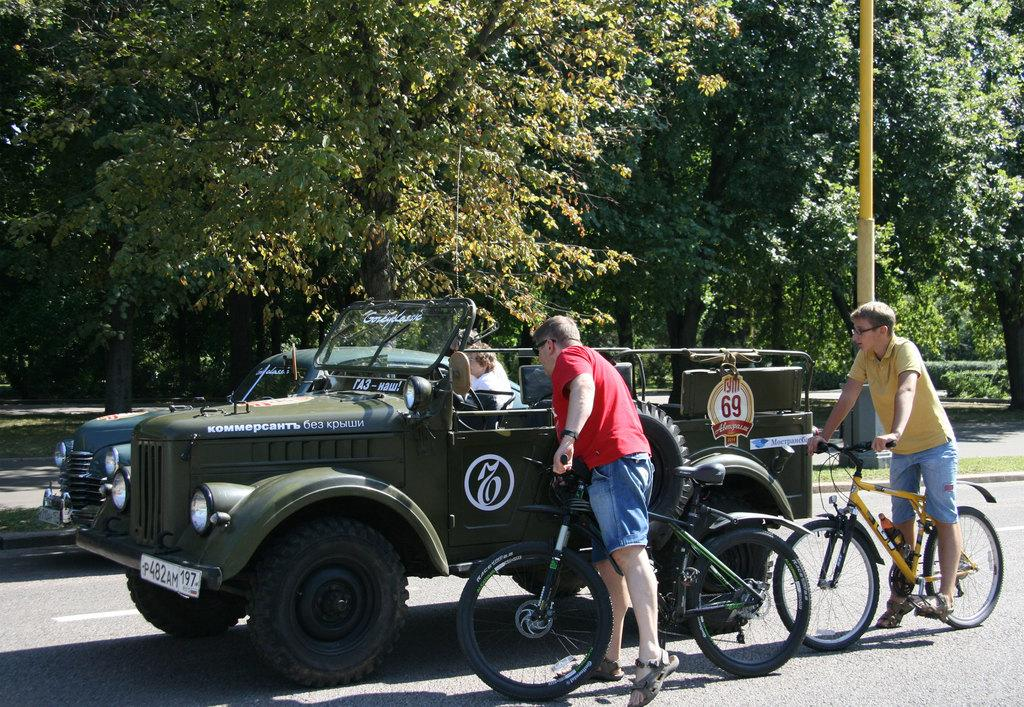What type of vehicles are present in the image? There is a jeep and a car in the image. What other mode of transportation can be seen in the image? There are two persons on a bicycle in the image. What natural element is visible in the image? There is a tree in the image. What man-made object is present in the image? There is a pole in the image. What type of fact can be seen floating in the air in the image? There is no fact visible in the image, as facts are not tangible objects that can be seen. 